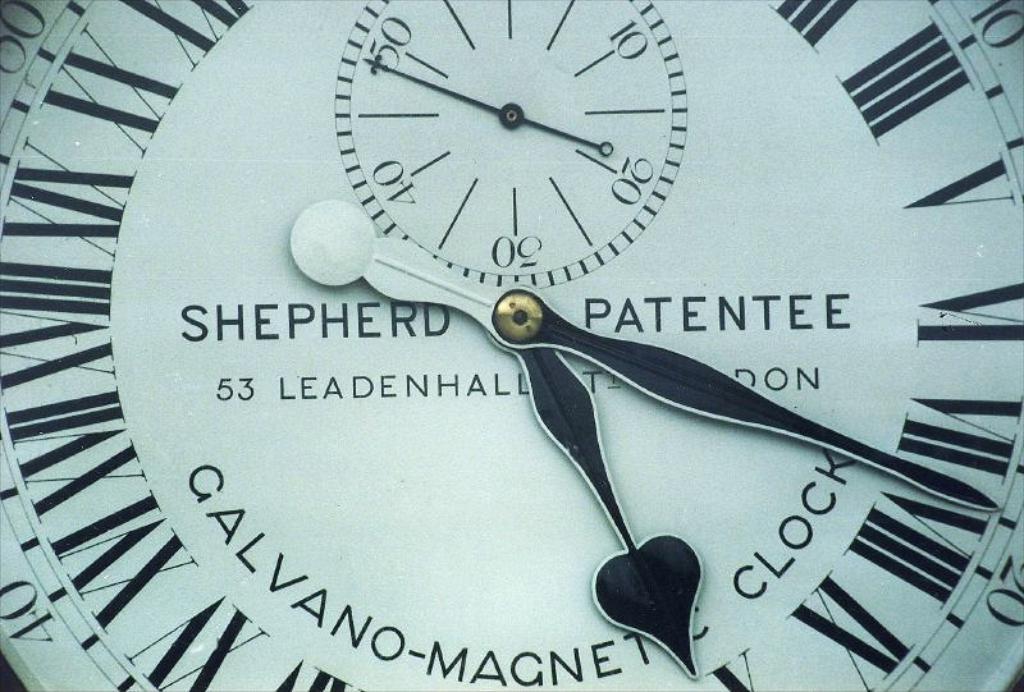What brand of clock is that?
Provide a succinct answer. Shepherd patentee. What is the time shown?
Your response must be concise. Unanswerable. 